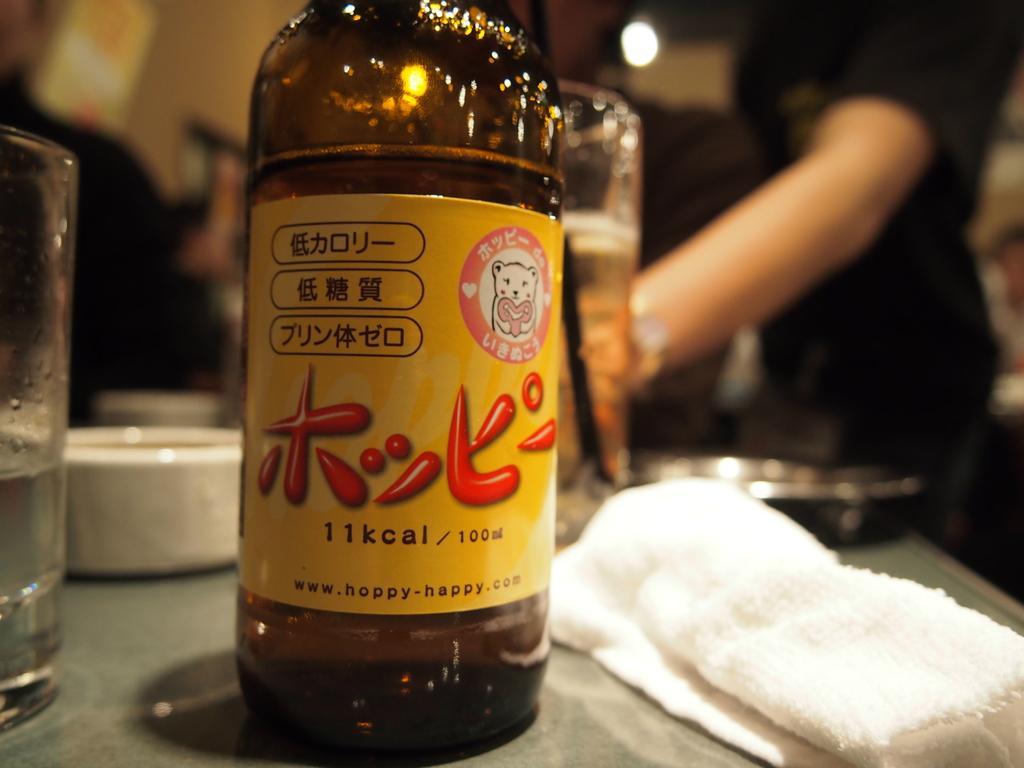Describe this image in one or two sentences. In this image we can see few people. There is a bottle and few other objects in the image. There is a cloth at the bottom right side of the image. There is a blur background in the image. 